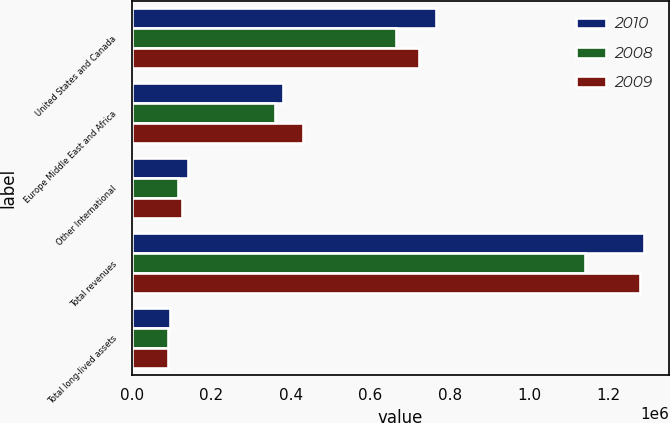<chart> <loc_0><loc_0><loc_500><loc_500><stacked_bar_chart><ecel><fcel>United States and Canada<fcel>Europe Middle East and Africa<fcel>Other International<fcel>Total revenues<fcel>Total long-lived assets<nl><fcel>2010<fcel>765793<fcel>380771<fcel>141890<fcel>1.28845e+06<fcel>97194<nl><fcel>2008<fcel>663832<fcel>360791<fcel>115177<fcel>1.1398e+06<fcel>90224<nl><fcel>2009<fcel>723247<fcel>430401<fcel>125417<fcel>1.27906e+06<fcel>91402<nl></chart> 